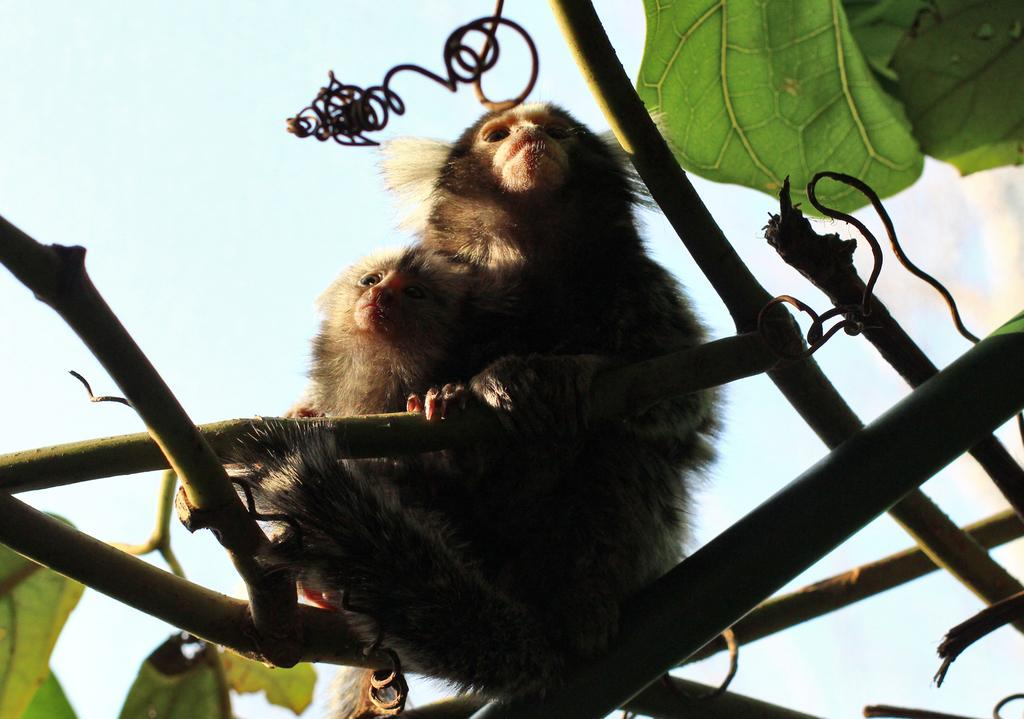What animals are present in the image? There are monkeys in the image. Where are the monkeys located? The monkeys are sitting on the branch of a tree. What can be seen in the background of the image? There is sky visible in the background of the image. What unit of measurement is used to describe the size of the monkeys' kick in the image? There is no kick or measurement mentioned in the image; it only shows monkeys sitting on a tree branch. 